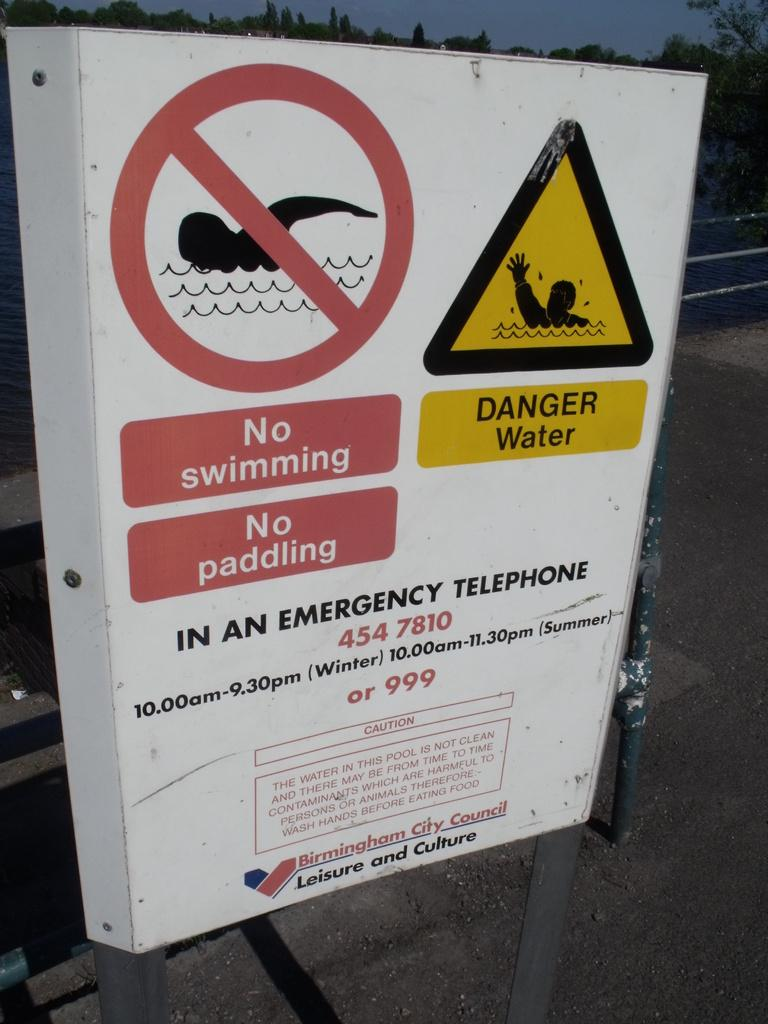<image>
Describe the image concisely. the words no swimming that are on a sign 